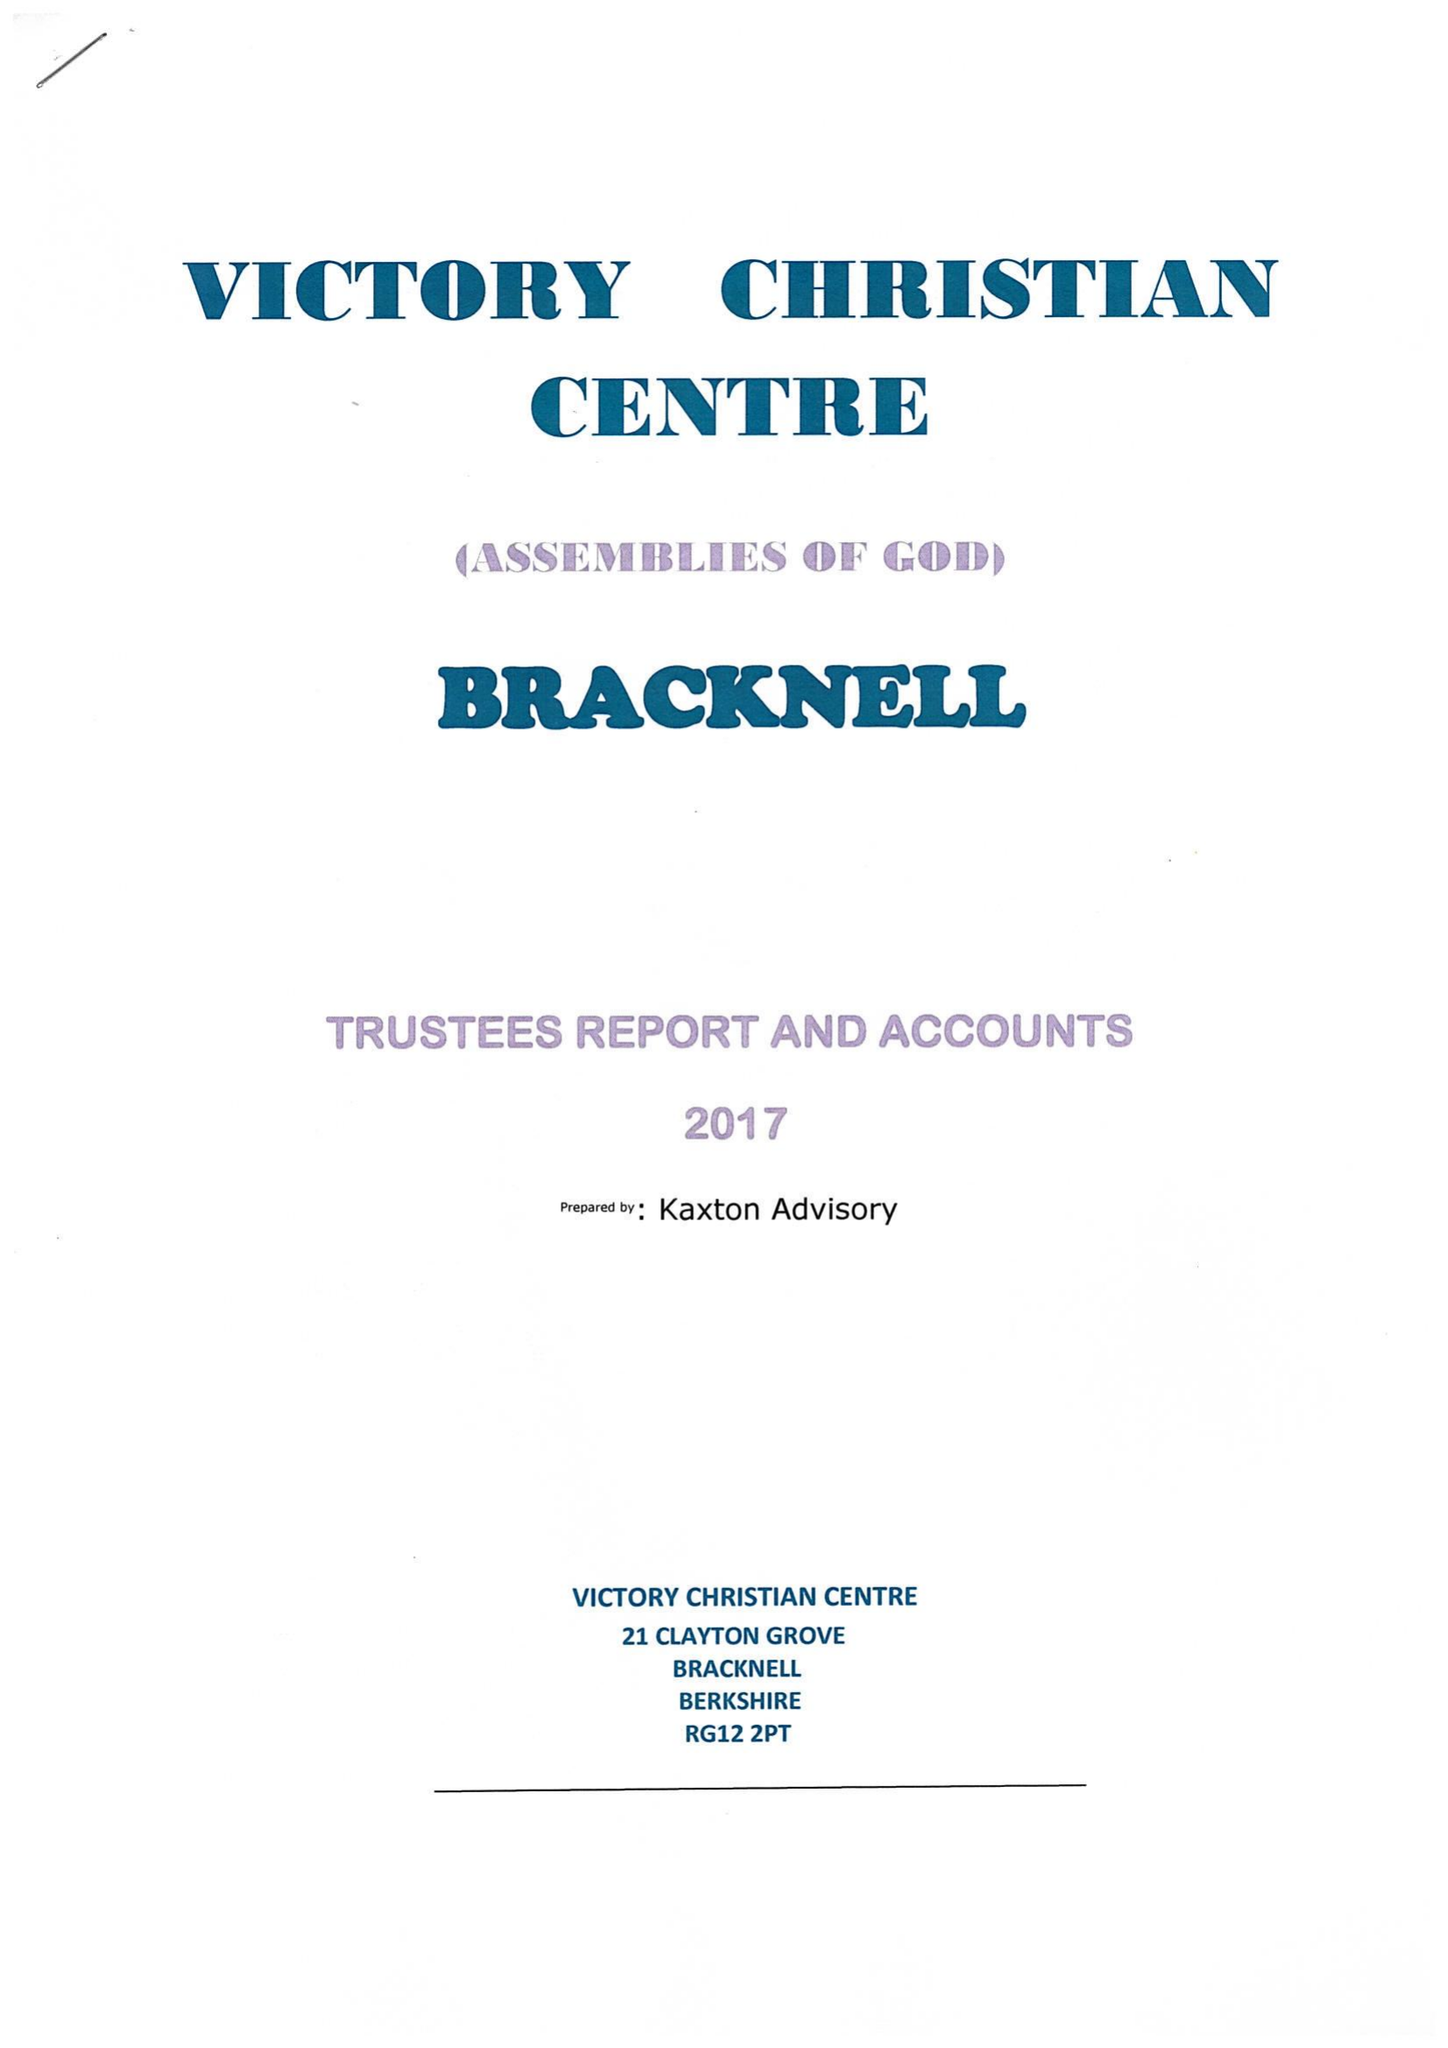What is the value for the charity_number?
Answer the question using a single word or phrase. 1170120 